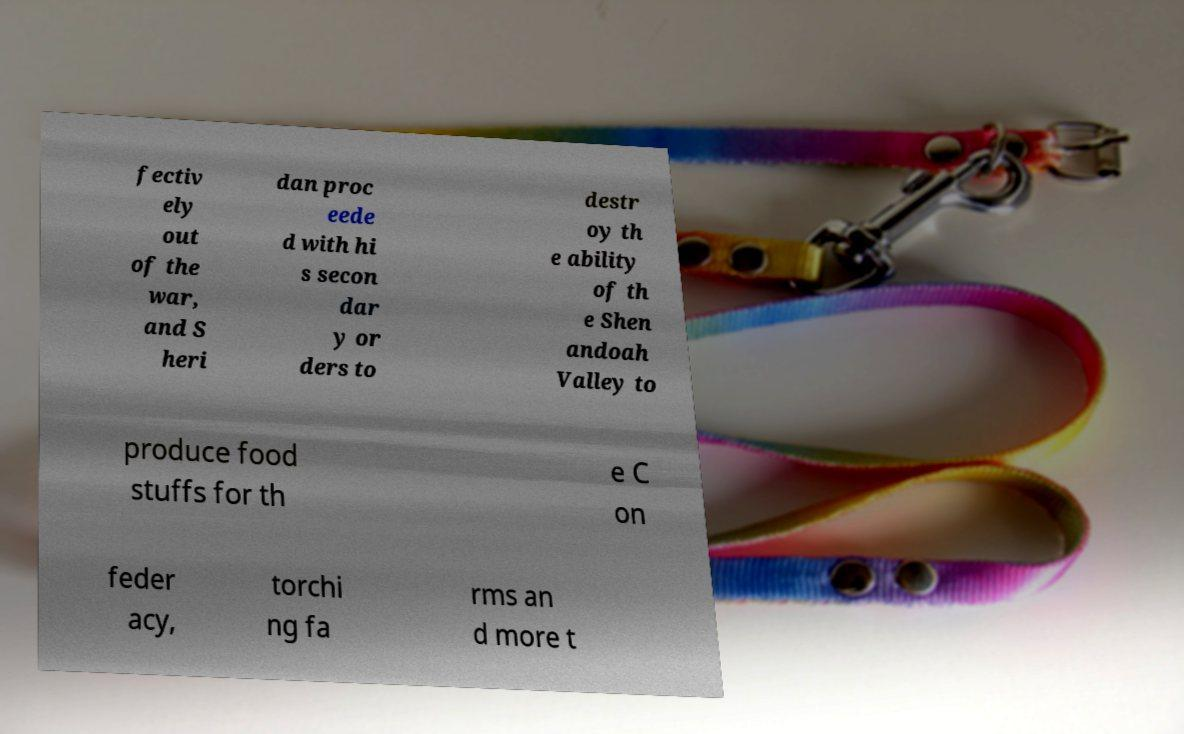Can you accurately transcribe the text from the provided image for me? fectiv ely out of the war, and S heri dan proc eede d with hi s secon dar y or ders to destr oy th e ability of th e Shen andoah Valley to produce food stuffs for th e C on feder acy, torchi ng fa rms an d more t 